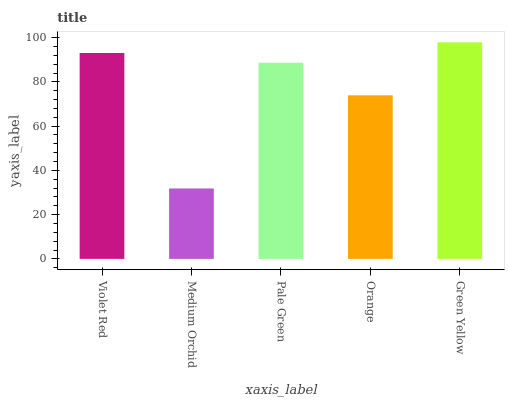Is Medium Orchid the minimum?
Answer yes or no. Yes. Is Green Yellow the maximum?
Answer yes or no. Yes. Is Pale Green the minimum?
Answer yes or no. No. Is Pale Green the maximum?
Answer yes or no. No. Is Pale Green greater than Medium Orchid?
Answer yes or no. Yes. Is Medium Orchid less than Pale Green?
Answer yes or no. Yes. Is Medium Orchid greater than Pale Green?
Answer yes or no. No. Is Pale Green less than Medium Orchid?
Answer yes or no. No. Is Pale Green the high median?
Answer yes or no. Yes. Is Pale Green the low median?
Answer yes or no. Yes. Is Orange the high median?
Answer yes or no. No. Is Violet Red the low median?
Answer yes or no. No. 